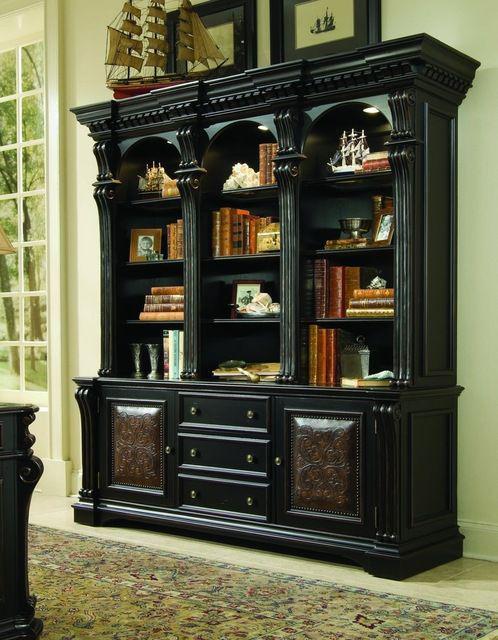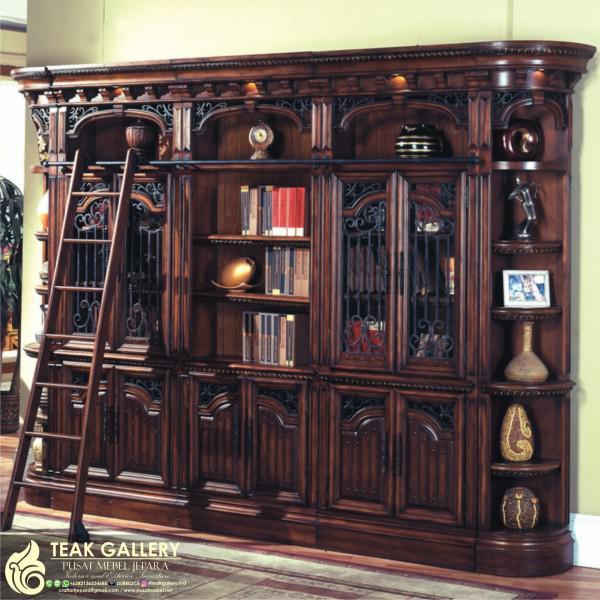The first image is the image on the left, the second image is the image on the right. Given the left and right images, does the statement "One large shelf unit is shown with an optional ladder accessory." hold true? Answer yes or no. Yes. 